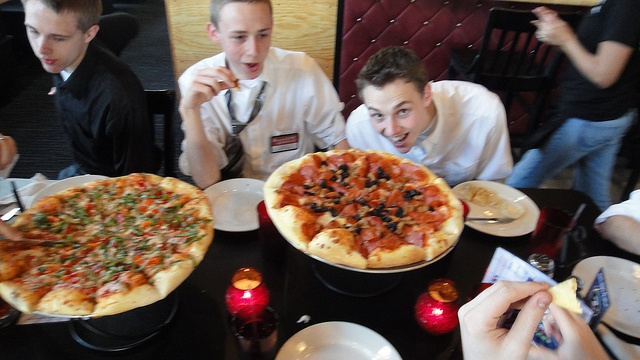Describe the objects in this image and their specific colors. I can see dining table in gray, black, darkgray, brown, and maroon tones, pizza in gray, brown, olive, and tan tones, people in gray, darkgray, and lightgray tones, pizza in gray, brown, and tan tones, and people in gray, black, and darkgray tones in this image. 